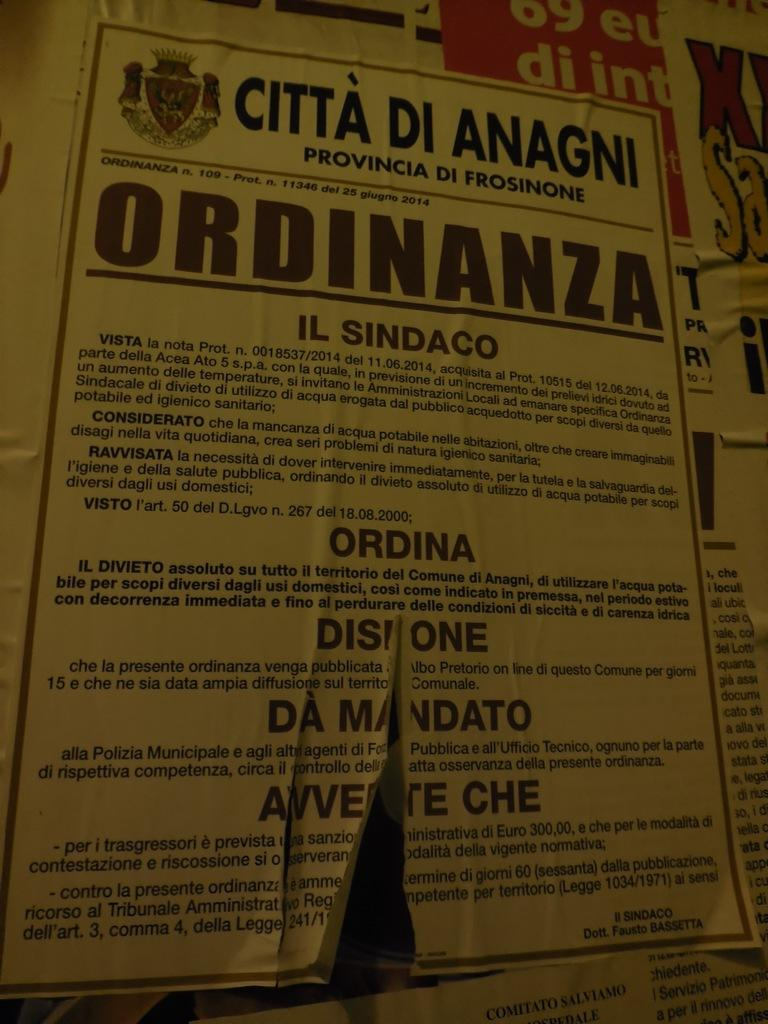Provide a one-sentence caption for the provided image. A flyer on a wall has the heading Citta Di Anagni. 